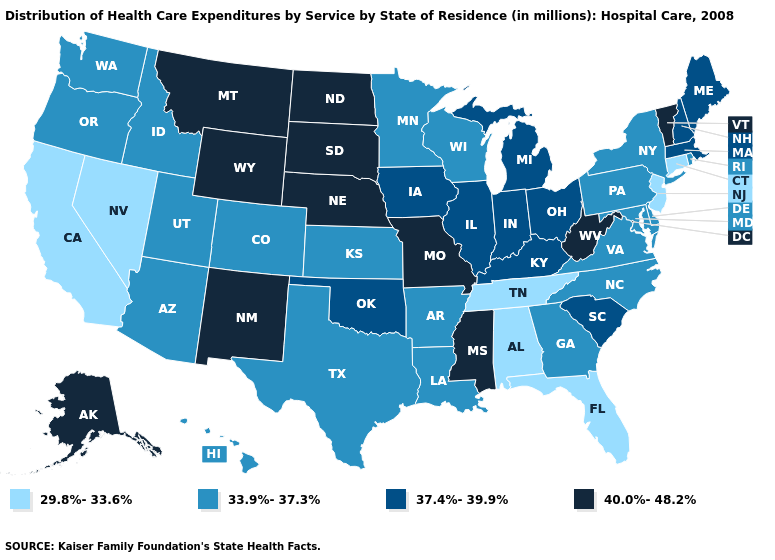What is the highest value in the West ?
Give a very brief answer. 40.0%-48.2%. Name the states that have a value in the range 33.9%-37.3%?
Short answer required. Arizona, Arkansas, Colorado, Delaware, Georgia, Hawaii, Idaho, Kansas, Louisiana, Maryland, Minnesota, New York, North Carolina, Oregon, Pennsylvania, Rhode Island, Texas, Utah, Virginia, Washington, Wisconsin. Name the states that have a value in the range 37.4%-39.9%?
Be succinct. Illinois, Indiana, Iowa, Kentucky, Maine, Massachusetts, Michigan, New Hampshire, Ohio, Oklahoma, South Carolina. Among the states that border Utah , which have the lowest value?
Keep it brief. Nevada. Name the states that have a value in the range 29.8%-33.6%?
Concise answer only. Alabama, California, Connecticut, Florida, Nevada, New Jersey, Tennessee. Which states have the highest value in the USA?
Short answer required. Alaska, Mississippi, Missouri, Montana, Nebraska, New Mexico, North Dakota, South Dakota, Vermont, West Virginia, Wyoming. Name the states that have a value in the range 40.0%-48.2%?
Give a very brief answer. Alaska, Mississippi, Missouri, Montana, Nebraska, New Mexico, North Dakota, South Dakota, Vermont, West Virginia, Wyoming. What is the value of Oklahoma?
Concise answer only. 37.4%-39.9%. Does Louisiana have a higher value than Florida?
Write a very short answer. Yes. What is the value of Nevada?
Quick response, please. 29.8%-33.6%. Name the states that have a value in the range 29.8%-33.6%?
Quick response, please. Alabama, California, Connecticut, Florida, Nevada, New Jersey, Tennessee. Among the states that border Vermont , does Massachusetts have the lowest value?
Answer briefly. No. Does Vermont have the highest value in the Northeast?
Short answer required. Yes. Does Rhode Island have the lowest value in the USA?
Give a very brief answer. No. Does Tennessee have the highest value in the South?
Write a very short answer. No. 